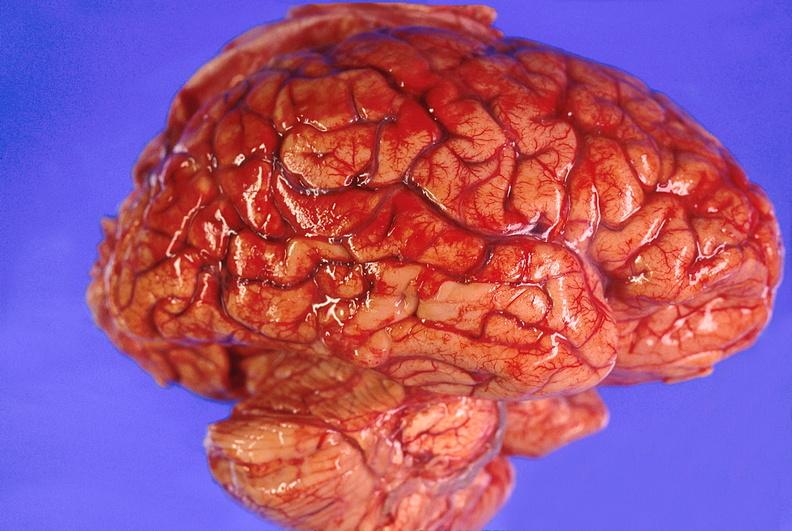s nervous present?
Answer the question using a single word or phrase. Yes 